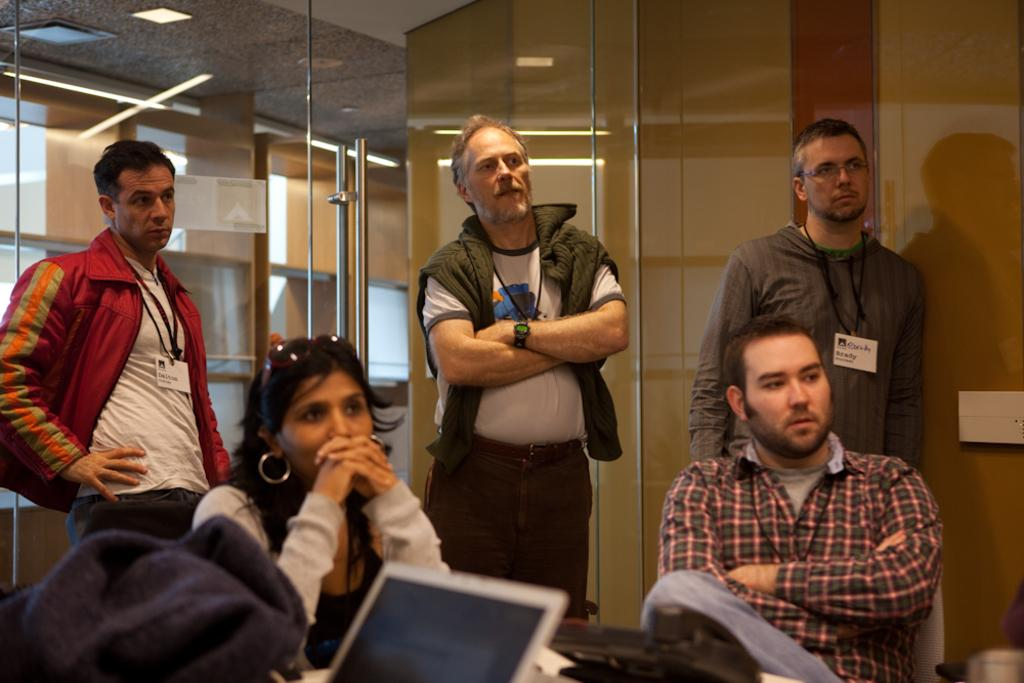Who or what can be seen in the image? There are people in the image. What electronic device is visible in the image? A laptop is visible in the image. What communication device is present in the image? A telephone is present in the image. What objects can be seen in the background of the image? There are glasses and lights visible in the background of the image. What type of knowledge is being shared on the sidewalk in the image? There is no sidewalk present in the image, and no knowledge is being shared. 